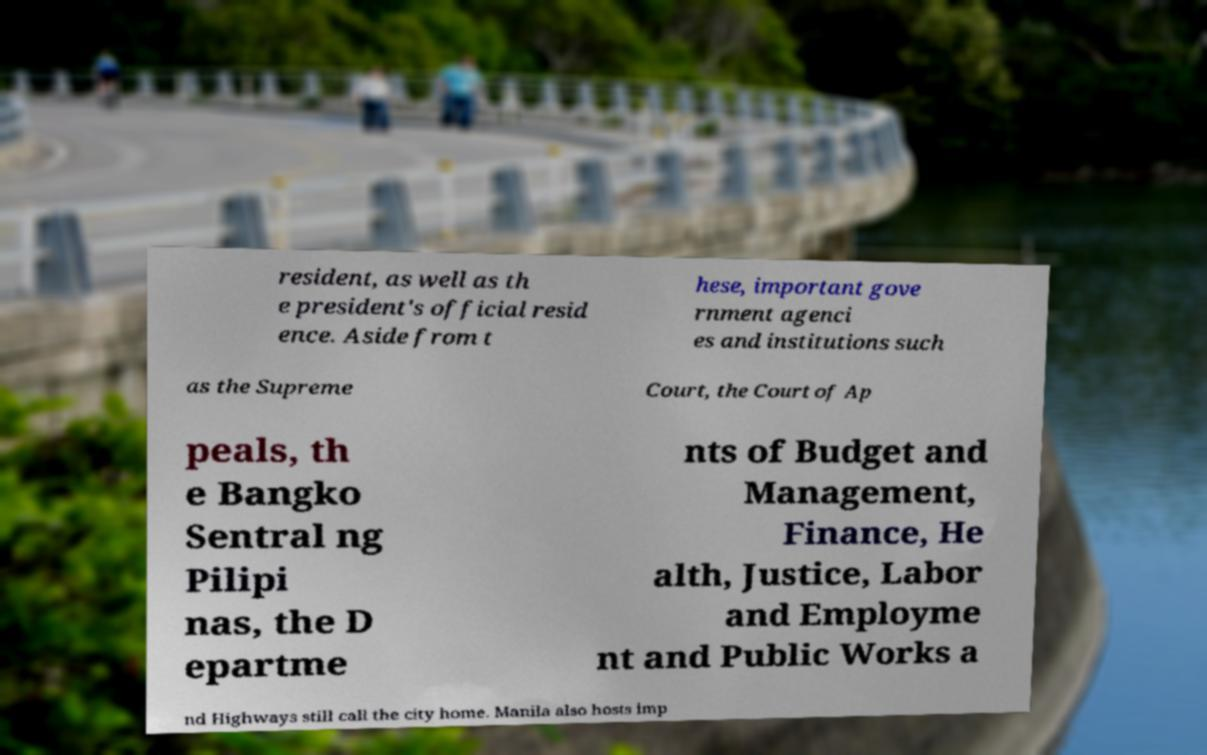What messages or text are displayed in this image? I need them in a readable, typed format. resident, as well as th e president's official resid ence. Aside from t hese, important gove rnment agenci es and institutions such as the Supreme Court, the Court of Ap peals, th e Bangko Sentral ng Pilipi nas, the D epartme nts of Budget and Management, Finance, He alth, Justice, Labor and Employme nt and Public Works a nd Highways still call the city home. Manila also hosts imp 